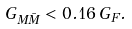Convert formula to latex. <formula><loc_0><loc_0><loc_500><loc_500>G _ { M \bar { M } } < 0 . 1 6 \, G _ { F } .</formula> 